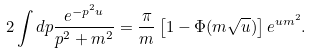<formula> <loc_0><loc_0><loc_500><loc_500>2 \int d p \frac { e ^ { - p ^ { 2 } u } } { p ^ { 2 } + m ^ { 2 } } = \frac { \pi } { m } \left [ 1 - \Phi ( m \sqrt { u } ) \right ] e ^ { u m ^ { 2 } } .</formula> 